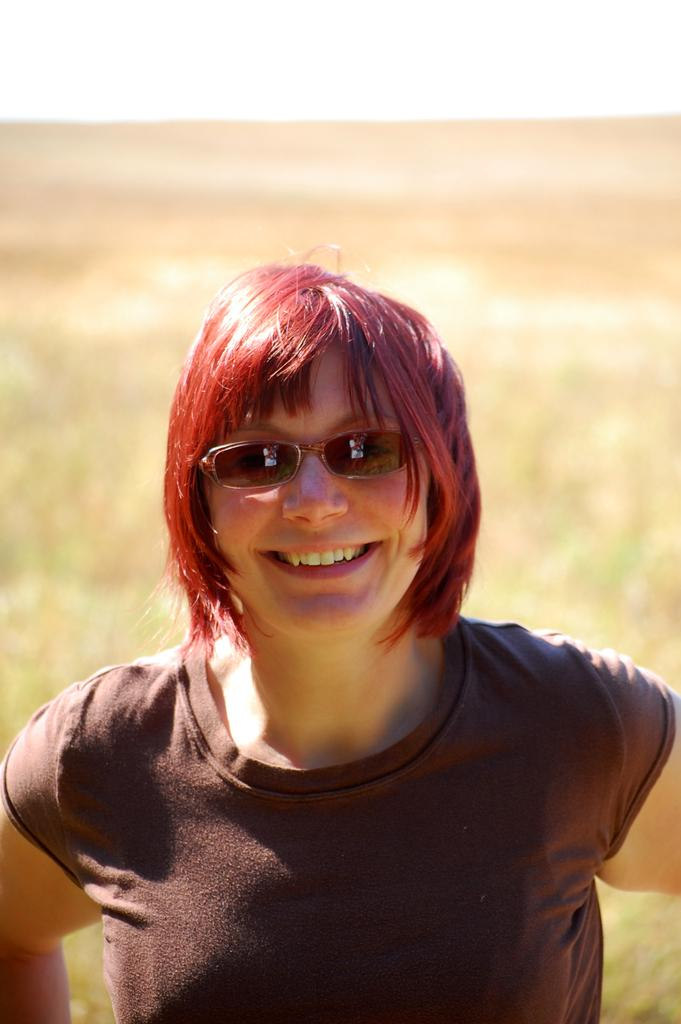Who is the main subject in the image? There is a woman in the image. What is the woman wearing? The woman is wearing a t-shirt. What expression does the woman have? The woman is smiling. What is the woman doing in the image? The woman is posing for the picture. What can be seen in the background of the image? There is land visible in the background of the image. What type of baseball can be seen on the plate in the image? There is no baseball or plate present in the image. What shape does the circle have in the image? There is no circle present in the image. 